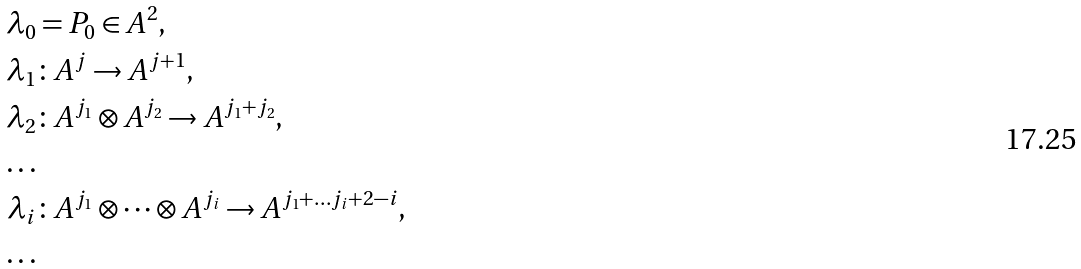Convert formula to latex. <formula><loc_0><loc_0><loc_500><loc_500>\lambda _ { 0 } & = P _ { 0 } \in A ^ { 2 } , \\ \lambda _ { 1 } & \colon A ^ { j } \to A ^ { j + 1 } , \\ \lambda _ { 2 } & \colon A ^ { j _ { 1 } } \otimes A ^ { j _ { 2 } } \to A ^ { j _ { 1 } + j _ { 2 } } , \\ \dots \\ \lambda _ { i } & \colon A ^ { j _ { 1 } } \otimes \dots \otimes A ^ { j _ { i } } \to A ^ { j _ { 1 } + \dots j _ { i } + 2 - i } , \\ \dots</formula> 